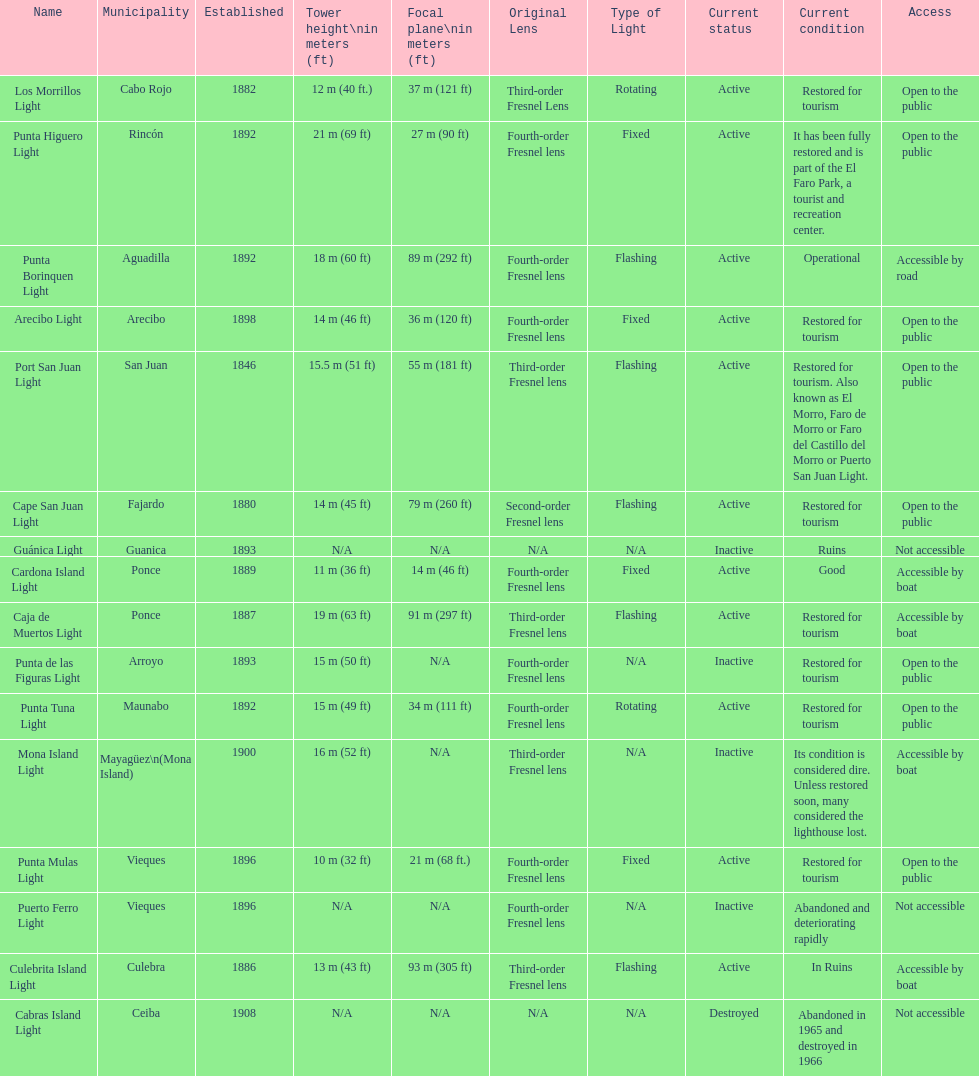Cardona island light and caja de muertos light are both located in what municipality? Ponce. 